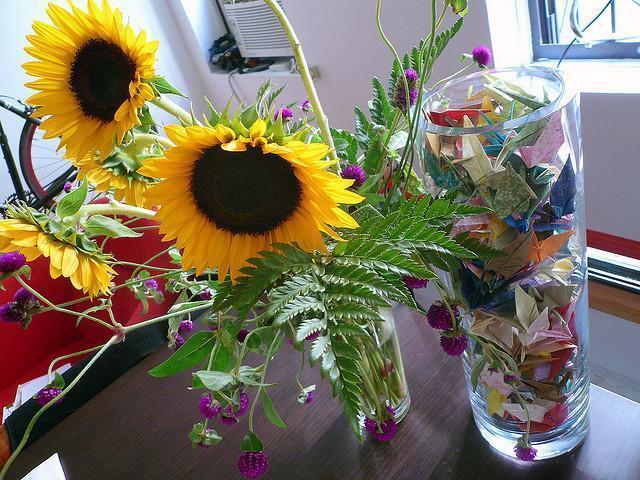How many vases can be seen?
Give a very brief answer. 2. How many men are riding skateboards?
Give a very brief answer. 0. 